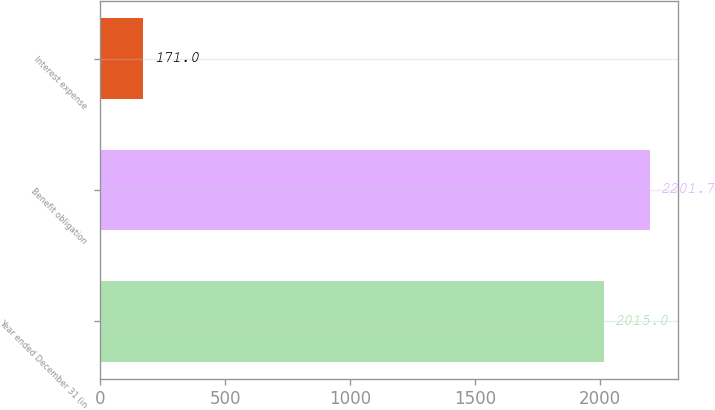Convert chart. <chart><loc_0><loc_0><loc_500><loc_500><bar_chart><fcel>Year ended December 31 (in<fcel>Benefit obligation<fcel>Interest expense<nl><fcel>2015<fcel>2201.7<fcel>171<nl></chart> 